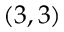Convert formula to latex. <formula><loc_0><loc_0><loc_500><loc_500>( 3 , 3 )</formula> 